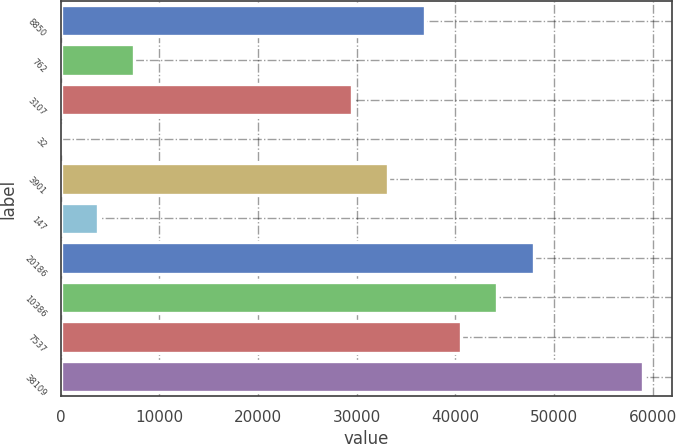Convert chart. <chart><loc_0><loc_0><loc_500><loc_500><bar_chart><fcel>8850<fcel>762<fcel>3107<fcel>32<fcel>3901<fcel>147<fcel>20186<fcel>10386<fcel>7537<fcel>38109<nl><fcel>36896<fcel>7425.6<fcel>29528.4<fcel>58<fcel>33212.2<fcel>3741.8<fcel>47947.4<fcel>44263.6<fcel>40579.8<fcel>58998.8<nl></chart> 